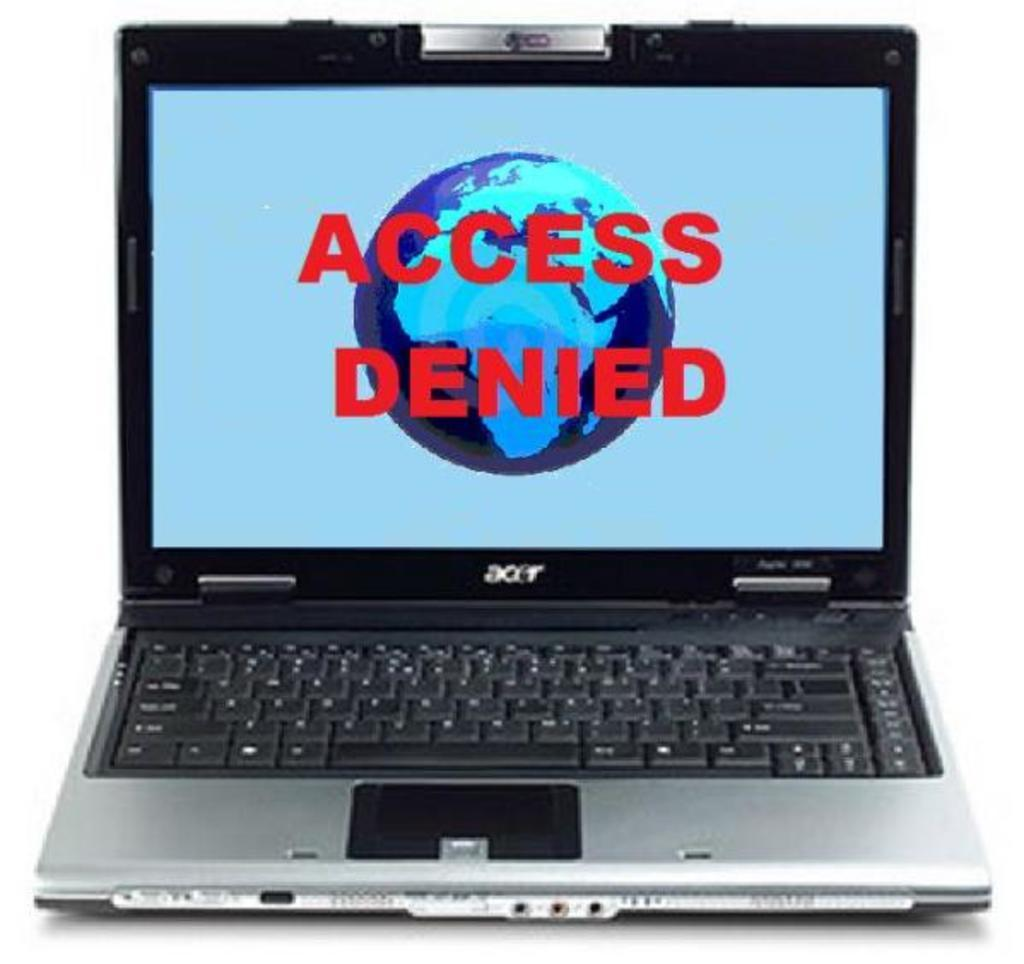Provide a one-sentence caption for the provided image. A laptop screen says Access Denied over a picture of the Earth. 